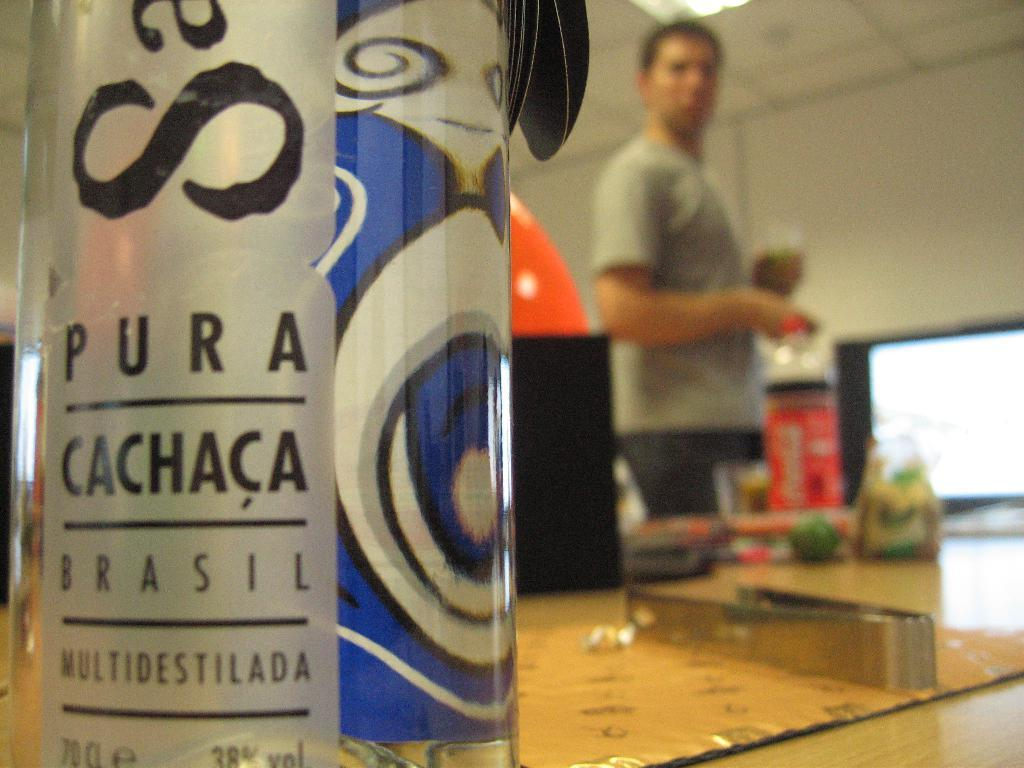Provide a one-sentence caption for the provided image. A bottle of pura chaca brasil alcohol, distilled multiple times. 